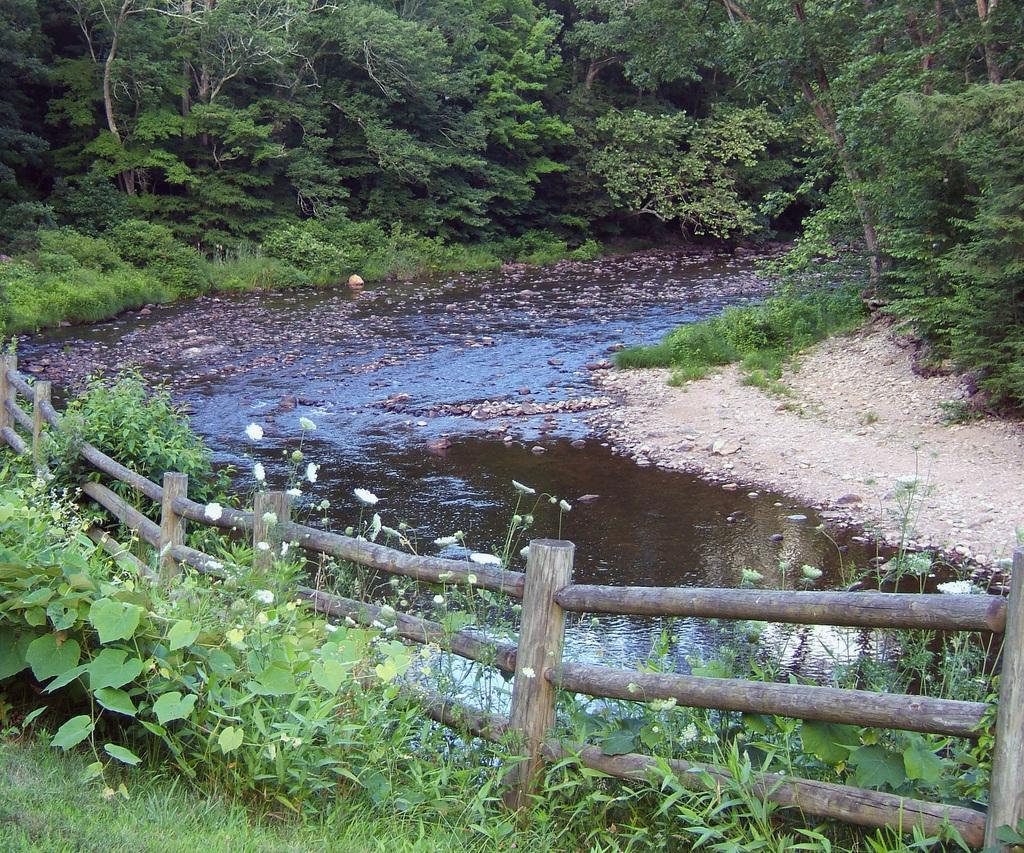How would you summarize this image in a sentence or two? In this image there is a lake in the middle of this image and there is fencing wall in the bottom of this image. There are some plants in the bottom left side of this image. There are some trees on the top of this image. 